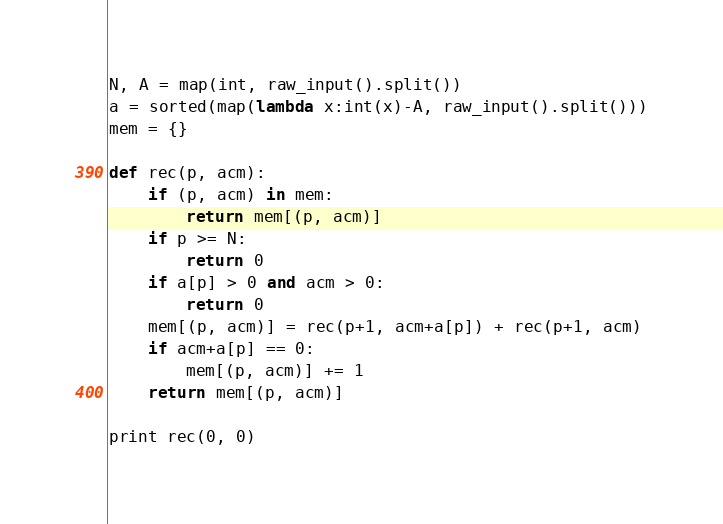<code> <loc_0><loc_0><loc_500><loc_500><_Python_>N, A = map(int, raw_input().split())
a = sorted(map(lambda x:int(x)-A, raw_input().split()))
mem = {}

def rec(p, acm):
    if (p, acm) in mem:
        return mem[(p, acm)]
    if p >= N:
        return 0
    if a[p] > 0 and acm > 0:
        return 0
    mem[(p, acm)] = rec(p+1, acm+a[p]) + rec(p+1, acm)
    if acm+a[p] == 0:
        mem[(p, acm)] += 1
    return mem[(p, acm)]

print rec(0, 0)
</code> 